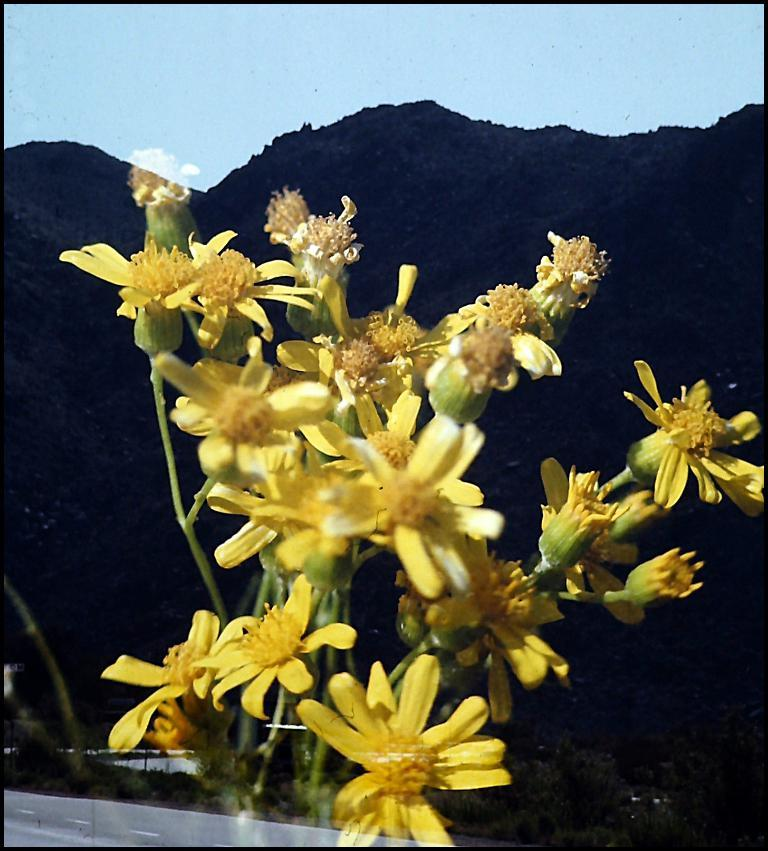What type of flora can be seen in the image? There are flowers in the image. What color are the flowers? The flowers are yellow in color. What can be seen in the background of the image? Hills and a part of the sky are visible in the background of the image. What is present in the sky? Clouds are present in the sky. Can you tell me the total cost of the team's equipment as listed on the receipt in the image? There is no team, receipt, or equipment present in the image; it features flowers, hills, and clouds. 